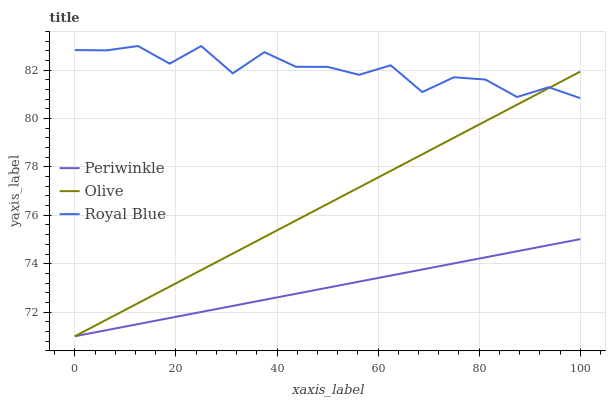Does Periwinkle have the minimum area under the curve?
Answer yes or no. Yes. Does Royal Blue have the maximum area under the curve?
Answer yes or no. Yes. Does Royal Blue have the minimum area under the curve?
Answer yes or no. No. Does Periwinkle have the maximum area under the curve?
Answer yes or no. No. Is Periwinkle the smoothest?
Answer yes or no. Yes. Is Royal Blue the roughest?
Answer yes or no. Yes. Is Royal Blue the smoothest?
Answer yes or no. No. Is Periwinkle the roughest?
Answer yes or no. No. Does Olive have the lowest value?
Answer yes or no. Yes. Does Royal Blue have the lowest value?
Answer yes or no. No. Does Royal Blue have the highest value?
Answer yes or no. Yes. Does Periwinkle have the highest value?
Answer yes or no. No. Is Periwinkle less than Royal Blue?
Answer yes or no. Yes. Is Royal Blue greater than Periwinkle?
Answer yes or no. Yes. Does Royal Blue intersect Olive?
Answer yes or no. Yes. Is Royal Blue less than Olive?
Answer yes or no. No. Is Royal Blue greater than Olive?
Answer yes or no. No. Does Periwinkle intersect Royal Blue?
Answer yes or no. No. 